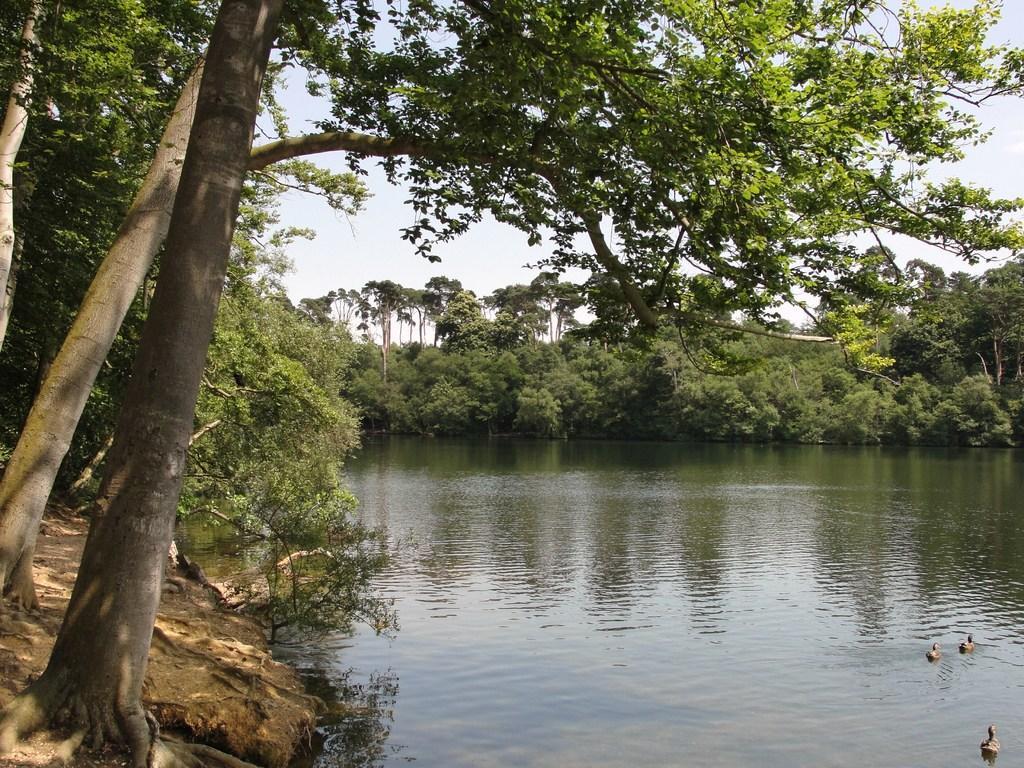In one or two sentences, can you explain what this image depicts? In this picture I can see ducks in the water and I can see few trees and a cloudy sky. 